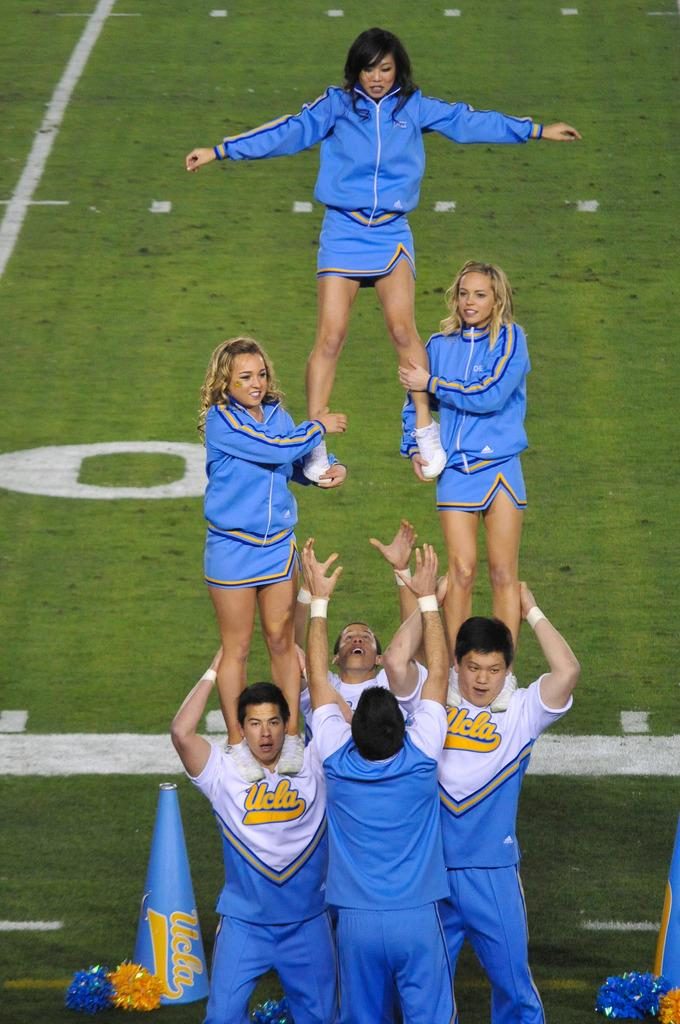What is happening in the image involving a group of people? The people in the image are performing stunts. What can be seen on the ground in the image? There are objects on the ground in the image. What type of cap is being worn by the person performing the stunt in the image? There is no cap visible in the image; the focus is on the stunts being performed by the group of people. 